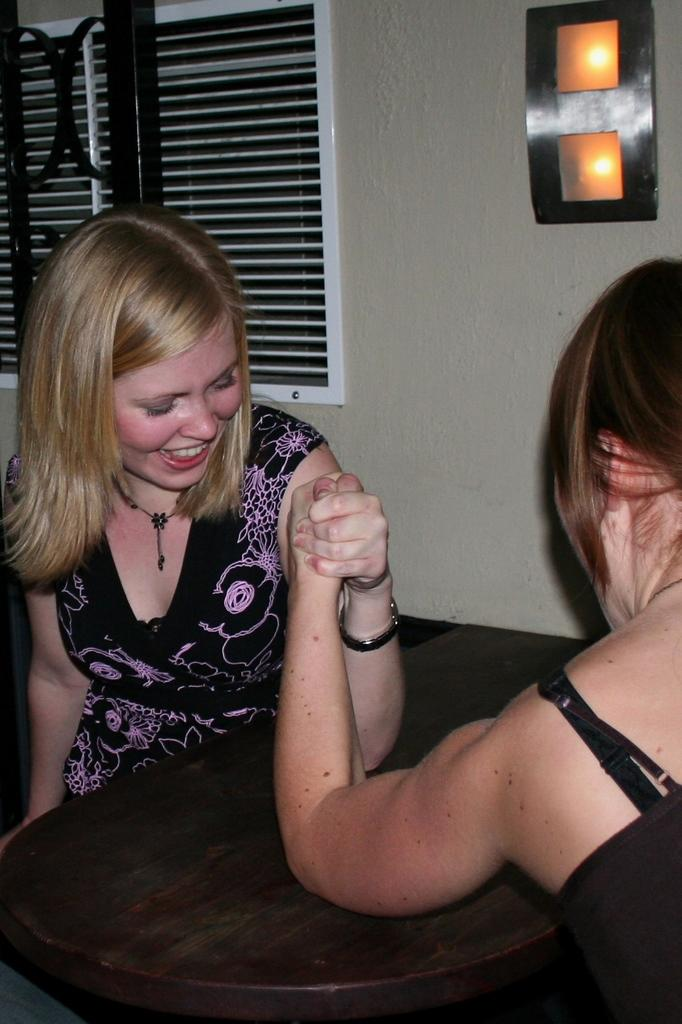How many people are in the image? There are two people in the image. What are the people doing in the image? The people are sitting. What is in front of the people? There is a wooden table in front of the people. What is behind the people? There is a wall behind the people. What can be seen in the wall? There is a window in the wall. What type of milk is being poured from the window in the image? There is no milk or pouring action present in the image; it only shows two people sitting at a table with a wall and window behind them. 